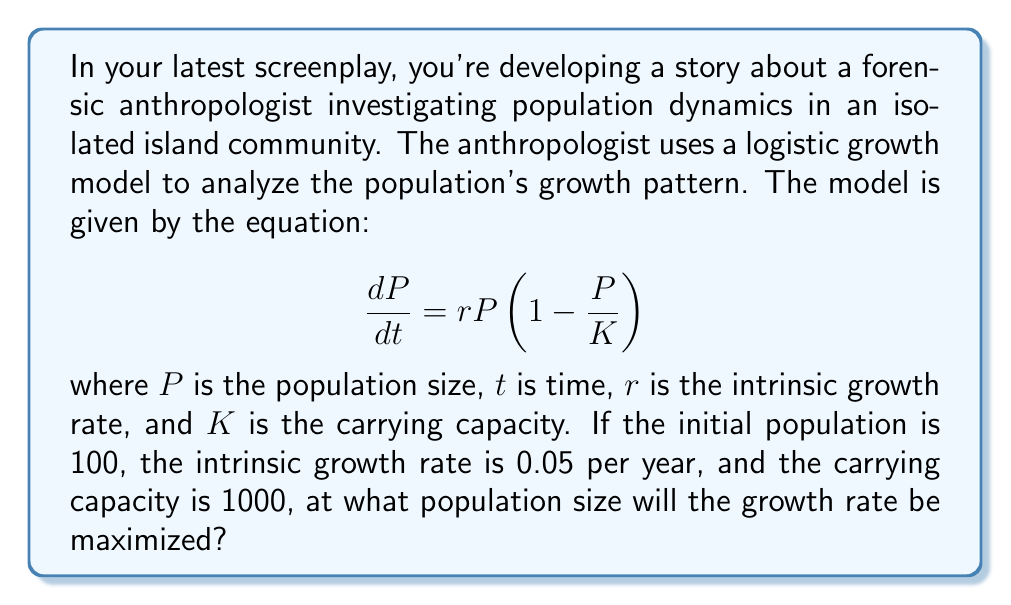Provide a solution to this math problem. To find the population size at which the growth rate is maximized, we need to follow these steps:

1) The growth rate is given by $\frac{dP}{dt}$. We need to find the maximum of this function.

2) Let's express $\frac{dP}{dt}$ as a function of $P$:

   $$\frac{dP}{dt} = 0.05P(1 - \frac{P}{1000})$$

3) To find the maximum, we need to differentiate this with respect to $P$ and set it to zero:

   $$\frac{d}{dP}(\frac{dP}{dt}) = 0.05(1 - \frac{P}{1000}) + 0.05P(-\frac{1}{1000}) = 0$$

4) Simplify:

   $$0.05 - \frac{0.05P}{1000} - \frac{0.05P}{1000} = 0$$
   $$0.05 - \frac{0.1P}{1000} = 0$$

5) Solve for $P$:

   $$\frac{0.1P}{1000} = 0.05$$
   $$P = 500$$

6) To confirm this is a maximum (not a minimum), we could take the second derivative and show it's negative at this point, but we'll skip that step for brevity.

Therefore, the growth rate is maximized when the population is half of the carrying capacity.
Answer: 500 